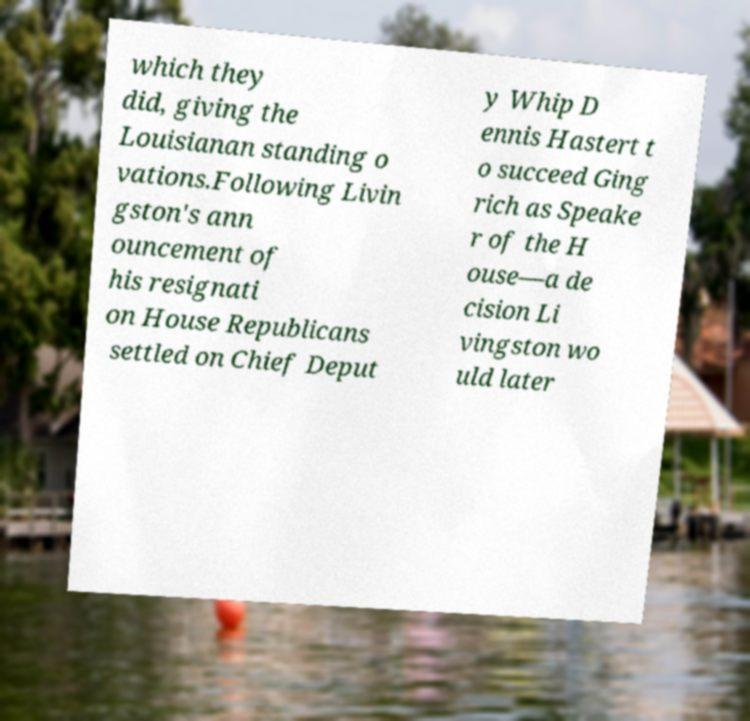For documentation purposes, I need the text within this image transcribed. Could you provide that? which they did, giving the Louisianan standing o vations.Following Livin gston's ann ouncement of his resignati on House Republicans settled on Chief Deput y Whip D ennis Hastert t o succeed Ging rich as Speake r of the H ouse—a de cision Li vingston wo uld later 